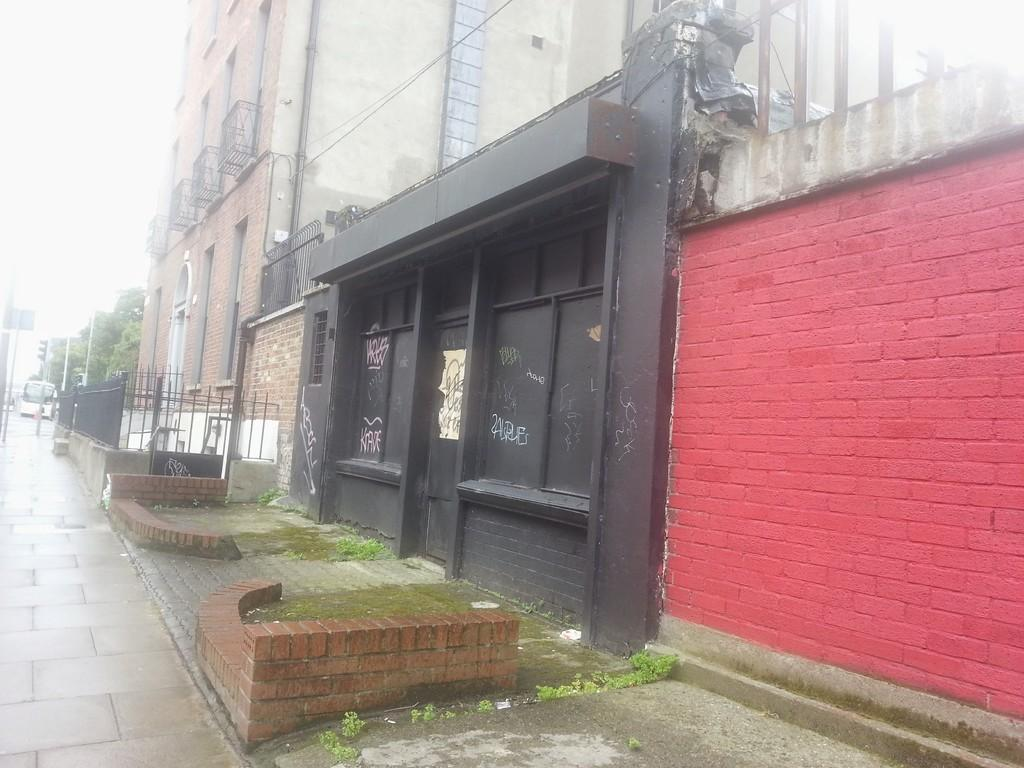What type of structures can be seen in the image? There are buildings in the image. What other natural elements are present in the image? There are trees in the image. What are the vertical structures in the image used for? There are poles in the image, which are likely used for supporting electrical wires or streetlights. What type of barrier is present in the image? There is fencing in the image. What mode of transportation can be seen on the left side of the image? A bus is present on the road on the left side of the image. What color of paint is being used to decorate the ducks in the image? There are no ducks present in the image, so there is no paint being used to decorate them. How many ducks are visible in the image? There are no ducks present in the image, so it is impossible to determine the number of ducks. 